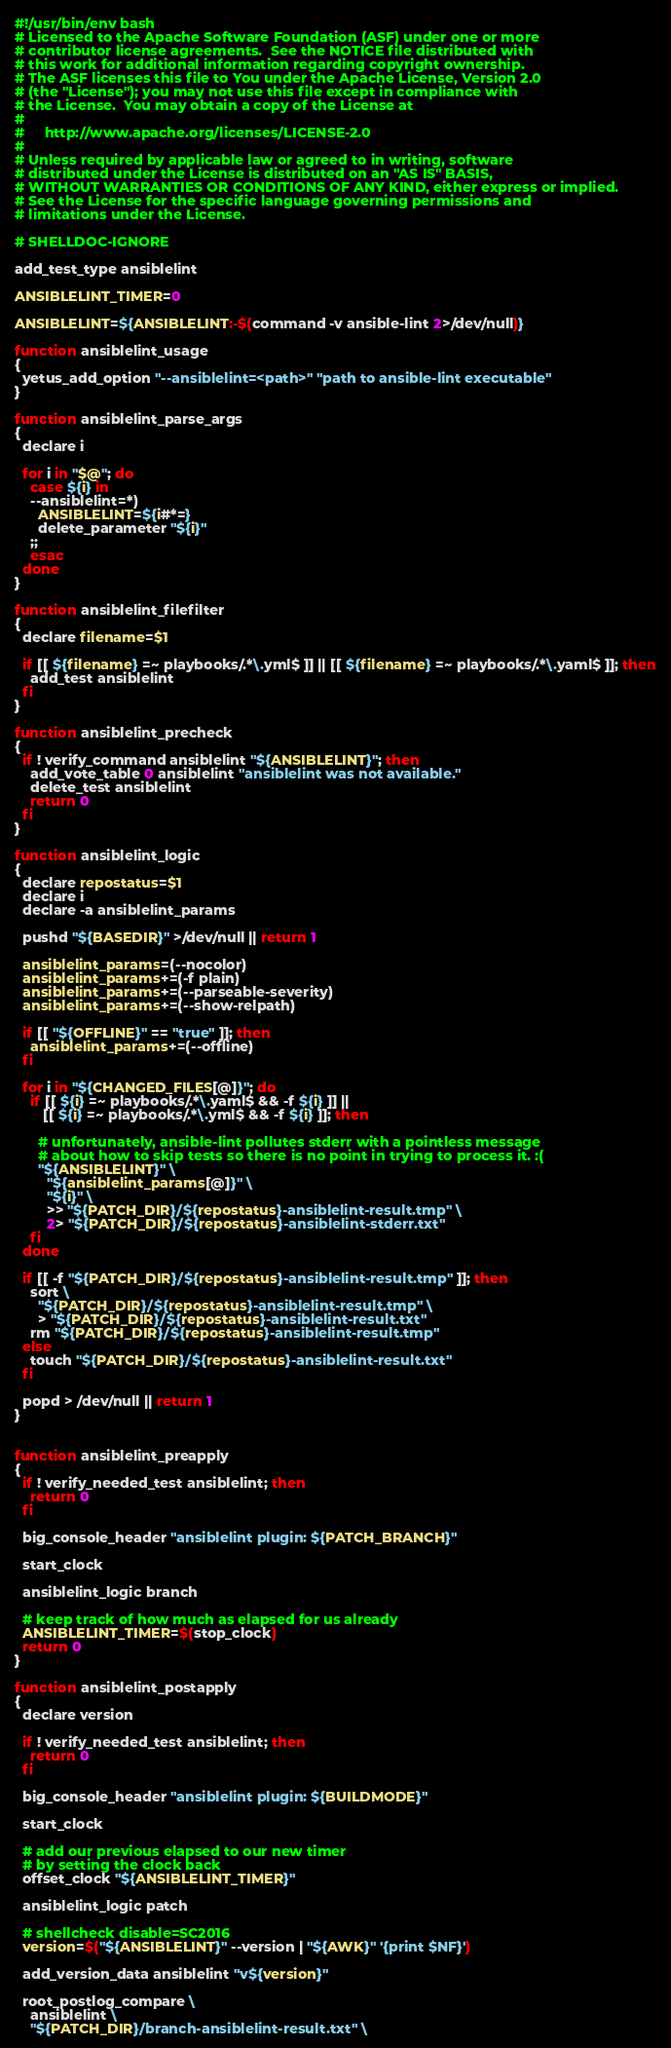Convert code to text. <code><loc_0><loc_0><loc_500><loc_500><_Bash_>#!/usr/bin/env bash
# Licensed to the Apache Software Foundation (ASF) under one or more
# contributor license agreements.  See the NOTICE file distributed with
# this work for additional information regarding copyright ownership.
# The ASF licenses this file to You under the Apache License, Version 2.0
# (the "License"); you may not use this file except in compliance with
# the License.  You may obtain a copy of the License at
#
#     http://www.apache.org/licenses/LICENSE-2.0
#
# Unless required by applicable law or agreed to in writing, software
# distributed under the License is distributed on an "AS IS" BASIS,
# WITHOUT WARRANTIES OR CONDITIONS OF ANY KIND, either express or implied.
# See the License for the specific language governing permissions and
# limitations under the License.

# SHELLDOC-IGNORE

add_test_type ansiblelint

ANSIBLELINT_TIMER=0

ANSIBLELINT=${ANSIBLELINT:-$(command -v ansible-lint 2>/dev/null)}

function ansiblelint_usage
{
  yetus_add_option "--ansiblelint=<path>" "path to ansible-lint executable"
}

function ansiblelint_parse_args
{
  declare i

  for i in "$@"; do
    case ${i} in
    --ansiblelint=*)
      ANSIBLELINT=${i#*=}
      delete_parameter "${i}"
    ;;
    esac
  done
}

function ansiblelint_filefilter
{
  declare filename=$1

  if [[ ${filename} =~ playbooks/.*\.yml$ ]] || [[ ${filename} =~ playbooks/.*\.yaml$ ]]; then
    add_test ansiblelint
  fi
}

function ansiblelint_precheck
{
  if ! verify_command ansiblelint "${ANSIBLELINT}"; then
    add_vote_table 0 ansiblelint "ansiblelint was not available."
    delete_test ansiblelint
    return 0
  fi
}

function ansiblelint_logic
{
  declare repostatus=$1
  declare i
  declare -a ansiblelint_params

  pushd "${BASEDIR}" >/dev/null || return 1

  ansiblelint_params=(--nocolor)
  ansiblelint_params+=(-f plain)
  ansiblelint_params+=(--parseable-severity)
  ansiblelint_params+=(--show-relpath)

  if [[ "${OFFLINE}" == "true" ]]; then
    ansiblelint_params+=(--offline)
  fi

  for i in "${CHANGED_FILES[@]}"; do
    if [[ ${i} =~ playbooks/.*\.yaml$ && -f ${i} ]] ||
       [[ ${i} =~ playbooks/.*\.yml$ && -f ${i} ]]; then

      # unfortunately, ansible-lint pollutes stderr with a pointless message
      # about how to skip tests so there is no point in trying to process it. :(
      "${ANSIBLELINT}" \
        "${ansiblelint_params[@]}" \
        "${i}" \
        >> "${PATCH_DIR}/${repostatus}-ansiblelint-result.tmp" \
        2> "${PATCH_DIR}/${repostatus}-ansiblelint-stderr.txt"
    fi
  done

  if [[ -f "${PATCH_DIR}/${repostatus}-ansiblelint-result.tmp" ]]; then
    sort \
      "${PATCH_DIR}/${repostatus}-ansiblelint-result.tmp" \
      > "${PATCH_DIR}/${repostatus}-ansiblelint-result.txt"
    rm "${PATCH_DIR}/${repostatus}-ansiblelint-result.tmp"
  else
    touch "${PATCH_DIR}/${repostatus}-ansiblelint-result.txt"
  fi

  popd > /dev/null || return 1
}


function ansiblelint_preapply
{
  if ! verify_needed_test ansiblelint; then
    return 0
  fi

  big_console_header "ansiblelint plugin: ${PATCH_BRANCH}"

  start_clock

  ansiblelint_logic branch

  # keep track of how much as elapsed for us already
  ANSIBLELINT_TIMER=$(stop_clock)
  return 0
}

function ansiblelint_postapply
{
  declare version

  if ! verify_needed_test ansiblelint; then
    return 0
  fi

  big_console_header "ansiblelint plugin: ${BUILDMODE}"

  start_clock

  # add our previous elapsed to our new timer
  # by setting the clock back
  offset_clock "${ANSIBLELINT_TIMER}"

  ansiblelint_logic patch

  # shellcheck disable=SC2016
  version=$("${ANSIBLELINT}" --version | "${AWK}" '{print $NF}')

  add_version_data ansiblelint "v${version}"

  root_postlog_compare \
    ansiblelint \
    "${PATCH_DIR}/branch-ansiblelint-result.txt" \</code> 